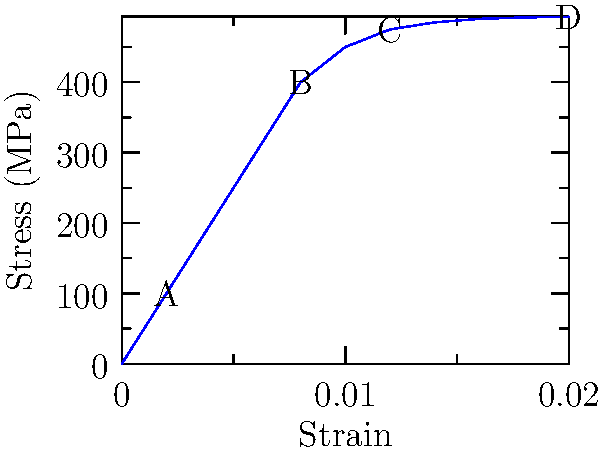In the stress-strain curve shown for a titanium alloy commonly used in Swedish aerospace engineering, identify the point that represents the yield strength of the material. How does this relate to the work of Swedish metallurgist Carl Benedicks, known for his contributions to the study of metal alloys? To answer this question, let's analyze the stress-strain curve and relate it to Carl Benedicks' work:

1. The stress-strain curve shows four labeled points: A, B, C, and D.

2. In a typical stress-strain curve:
   - The linear elastic region is at the beginning of the curve.
   - The yield point is where the curve starts to deviate from linearity.
   - After the yield point, the material enters the plastic deformation region.

3. Examining the curve:
   - Point A is in the linear elastic region.
   - Point B is where the curve starts to deviate from linearity, indicating the yield point.
   - Points C and D are in the plastic deformation region.

4. Therefore, point B represents the yield strength of the material.

5. Carl Benedicks, a Swedish metallurgist, made significant contributions to the study of metal alloys:
   - He worked on the properties and structures of various metals and alloys.
   - His research helped in understanding how different elements affect the mechanical properties of alloys.
   - The yield strength, represented by point B, is a crucial property in metallurgy and materials science.

6. Benedicks' work relates to this curve in several ways:
   - He studied how alloying elements can improve the mechanical properties of metals, including yield strength.
   - His research contributes to our understanding of how to engineer alloys with specific stress-strain characteristics.
   - The titanium alloy shown in the graph likely benefited from the type of metallurgical research Benedicks pioneered.

By identifying the yield strength and relating it to Benedicks' work, we can appreciate how Swedish contributions to metallurgy have influenced modern materials used in aerospace engineering.
Answer: Point B; it represents the yield strength, relating to Benedicks' research on improving mechanical properties of metal alloys. 